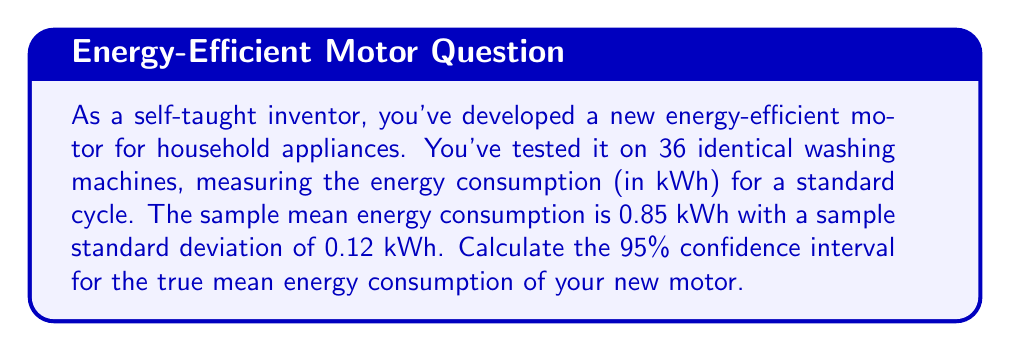Could you help me with this problem? To calculate the confidence interval, we'll use the t-distribution because we're working with a sample size less than 30 and don't know the population standard deviation. Here are the steps:

1. Identify the known values:
   - Sample size: $n = 36$
   - Sample mean: $\bar{x} = 0.85$ kWh
   - Sample standard deviation: $s = 0.12$ kWh
   - Confidence level: 95% (α = 0.05)

2. Find the critical t-value:
   - Degrees of freedom: $df = n - 1 = 35$
   - For a 95% confidence interval, we need $t_{0.025, 35}$
   - Using a t-table or calculator, we find $t_{0.025, 35} \approx 2.030$

3. Calculate the margin of error:
   $E = t_{0.025, 35} \cdot \frac{s}{\sqrt{n}} = 2.030 \cdot \frac{0.12}{\sqrt{36}} \approx 0.0406$

4. Compute the confidence interval:
   Lower bound: $\bar{x} - E = 0.85 - 0.0406 = 0.8094$
   Upper bound: $\bar{x} + E = 0.85 + 0.0406 = 0.8906$

Therefore, the 95% confidence interval is (0.8094, 0.8906) kWh.
Answer: (0.8094, 0.8906) kWh 